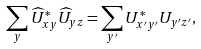Convert formula to latex. <formula><loc_0><loc_0><loc_500><loc_500>\sum _ { y } \widehat { U } _ { x y } ^ { * } \widehat { U } _ { y z } = \sum _ { y ^ { \prime } } U _ { x ^ { \prime } y ^ { \prime } } ^ { * } U _ { y ^ { \prime } z ^ { \prime } } ,</formula> 